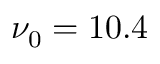<formula> <loc_0><loc_0><loc_500><loc_500>\nu _ { 0 } = 1 0 . 4</formula> 